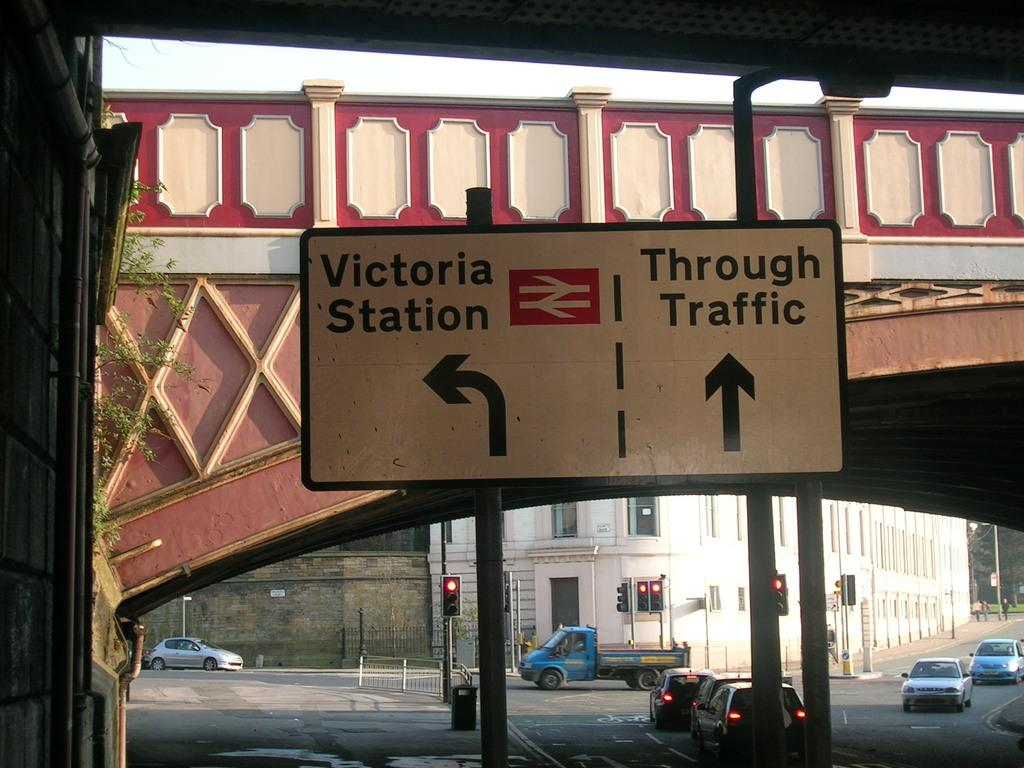<image>
Render a clear and concise summary of the photo. A street sign explains that Victoria Station is left and Through Traffic is straight ahead. 